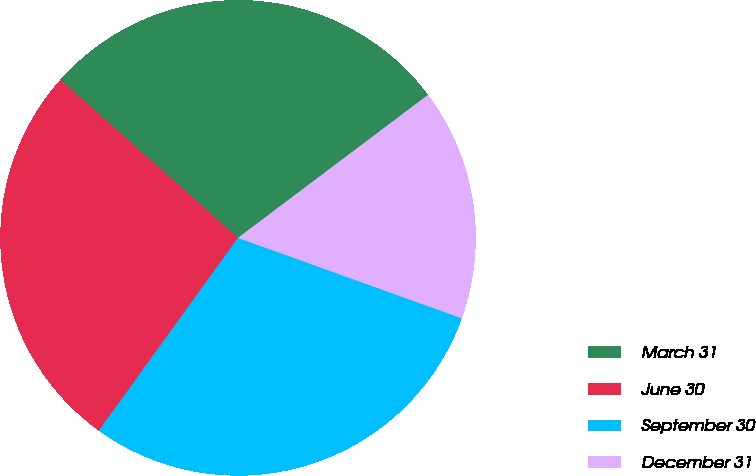Convert chart. <chart><loc_0><loc_0><loc_500><loc_500><pie_chart><fcel>March 31<fcel>June 30<fcel>September 30<fcel>December 31<nl><fcel>28.16%<fcel>26.63%<fcel>29.46%<fcel>15.76%<nl></chart> 